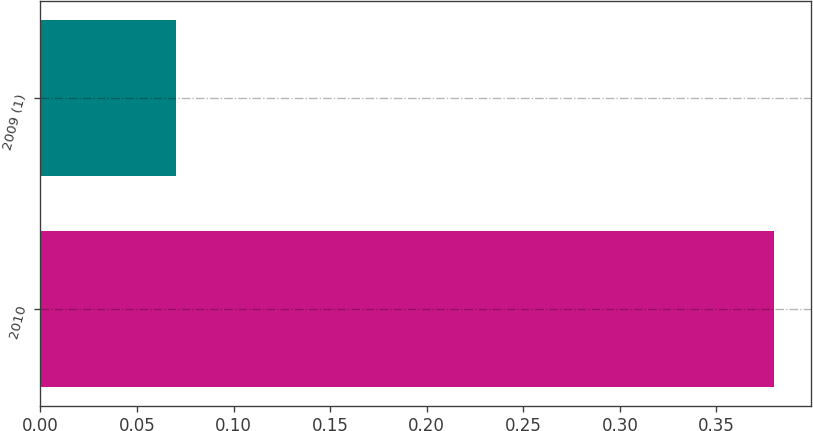Convert chart. <chart><loc_0><loc_0><loc_500><loc_500><bar_chart><fcel>2010<fcel>2009 (1)<nl><fcel>0.38<fcel>0.07<nl></chart> 